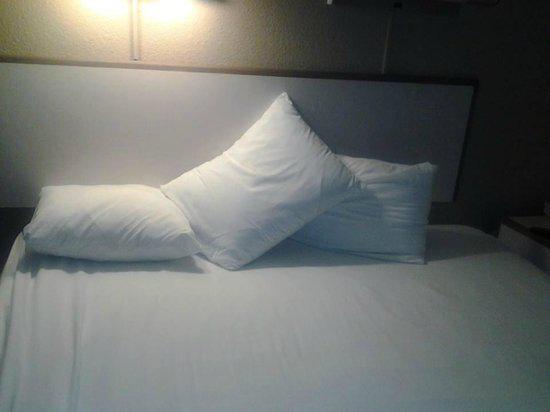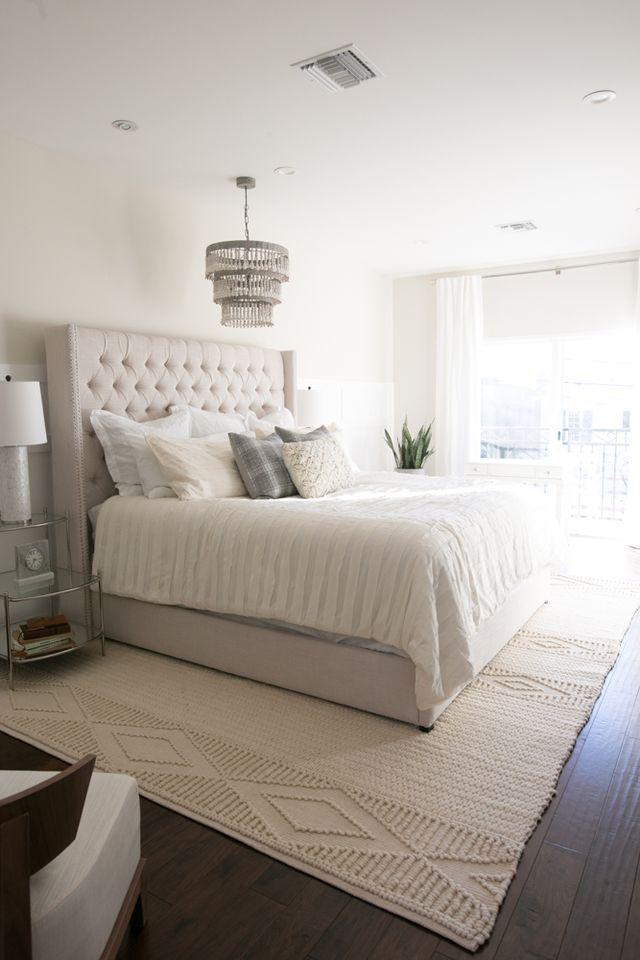The first image is the image on the left, the second image is the image on the right. Assess this claim about the two images: "An image shows pillows in front of a non-tufted headboard.". Correct or not? Answer yes or no. Yes. The first image is the image on the left, the second image is the image on the right. For the images shown, is this caption "A window near the bed is letting in natural light." true? Answer yes or no. Yes. 